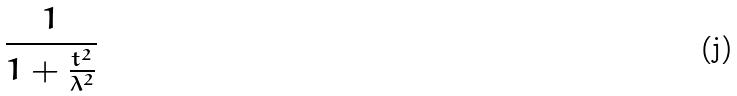Convert formula to latex. <formula><loc_0><loc_0><loc_500><loc_500>\frac { 1 } { 1 + \frac { t ^ { 2 } } { \lambda ^ { 2 } } }</formula> 